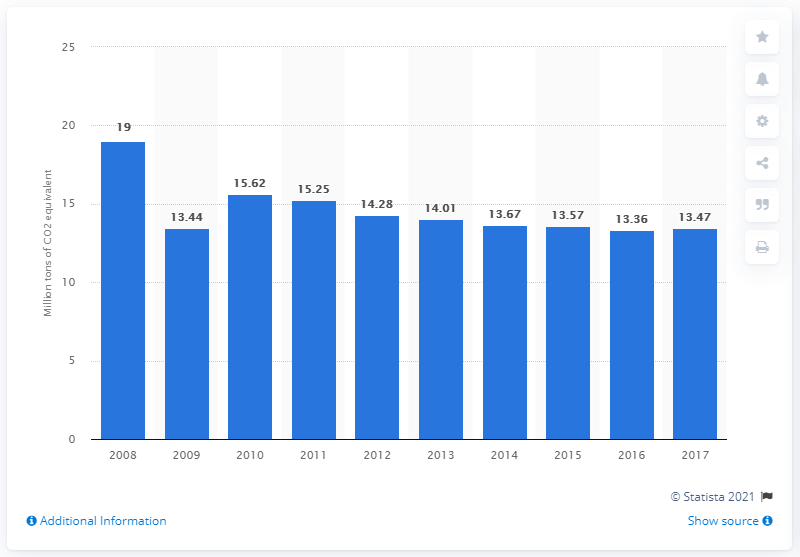How much CO2 equivalent did Belgium emit from fuel combustion in 2017? In 2017, Belgium emitted 13.47 million tons of CO2 equivalent from fuel combustion, marking a consistent trend in the country's efforts to manage and reduce its carbon emissions over the years. 